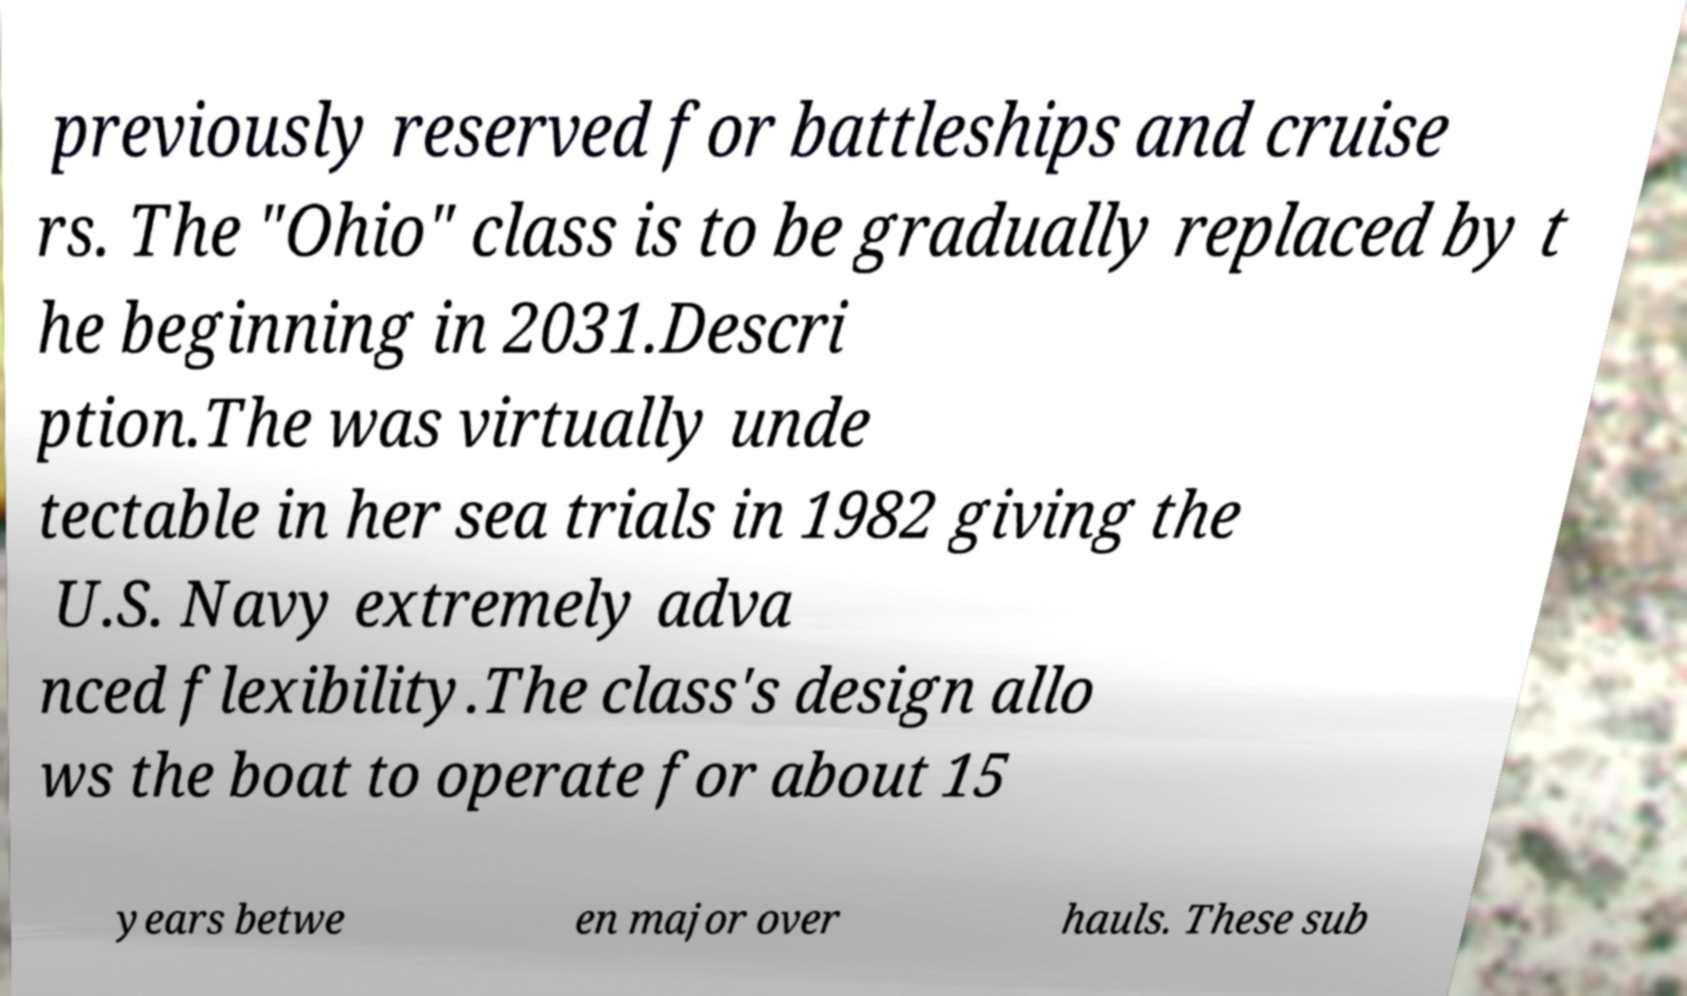For documentation purposes, I need the text within this image transcribed. Could you provide that? previously reserved for battleships and cruise rs. The "Ohio" class is to be gradually replaced by t he beginning in 2031.Descri ption.The was virtually unde tectable in her sea trials in 1982 giving the U.S. Navy extremely adva nced flexibility.The class's design allo ws the boat to operate for about 15 years betwe en major over hauls. These sub 